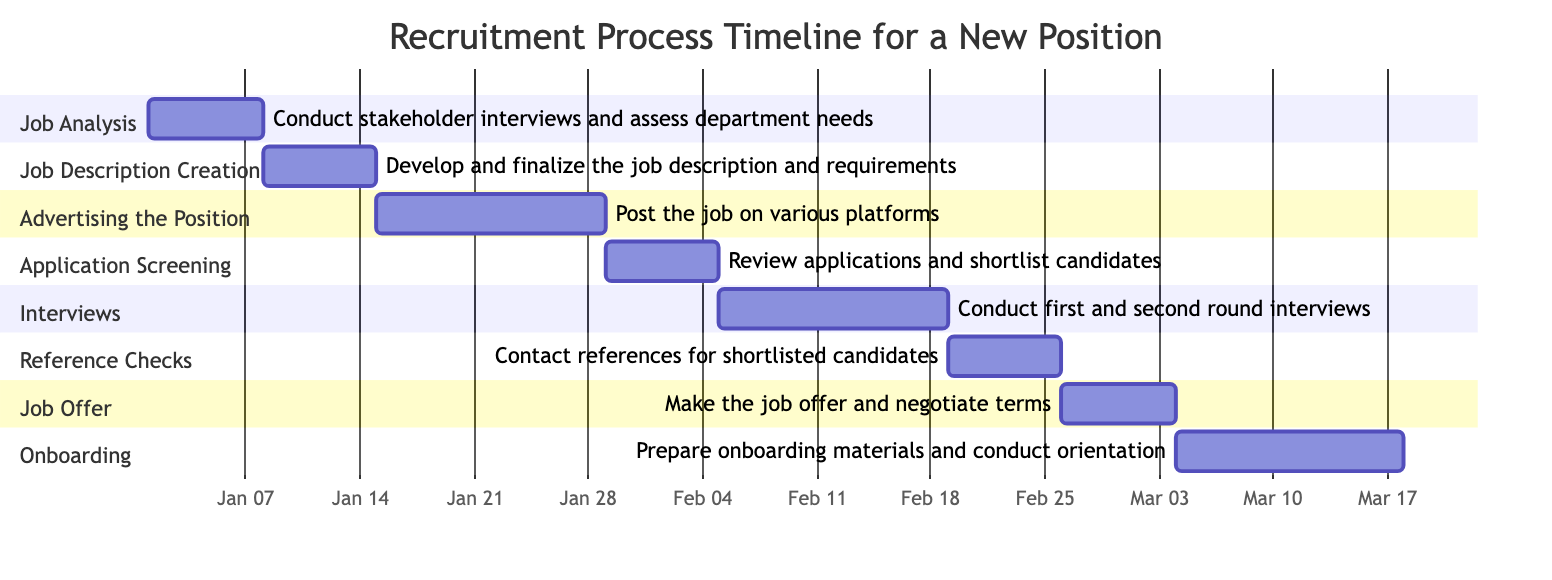What is the duration of the "Job Analysis" phase? The duration for the "Job Analysis" phase is explicitly noted in the diagram data as "1 week."
Answer: 1 week When does the "Interviews" phase start? The "Interviews" phase starts immediately after the "Application Screening" phase ends, which is noted to be on February 4, 2024. Therefore, it begins on February 5, 2024.
Answer: February 5, 2024 How many weeks does the entire recruitment process take? To find the total duration, we identify the end of the last phase, "Onboarding," which concludes on March 17, 2024. The recruitment process starts on January 1, 2024, leading to a total duration of about 10 weeks.
Answer: 10 weeks Which phase follows "Reference Checks"? The "Job Offer" phase directly follows "Reference Checks," as indicated by the sequential flow in the diagram.
Answer: Job Offer What are the tasks involved in the "Advertising the Position" phase? The task noted for the "Advertising the Position" phase is to "Post the job on various platforms (LinkedIn, company website, etc.)," as provided in the phase description.
Answer: Post the job on various platforms (LinkedIn, company website, etc.) How many tasks are involved in the "Interviews" phase? There is one task specified for the "Interviews" phase, which is to "Conduct first and second round interviews," as detailed in the diagram.
Answer: Conduct first and second round interviews What is the start date of the "Onboarding" phase? The "Onboarding" phase starts right after the "Job Offer" phase, which concludes on March 3, 2024. Thus, "Onboarding" begins on March 4, 2024.
Answer: March 4, 2024 How does the “Job Description Creation” phase relate to the “Job Analysis” phase? The "Job Description Creation" phase begins immediately after the "Job Analysis" phase ends, indicating a direct sequential relationship between these two phases in the recruitment process timeline.
Answer: Sequentially follows What is the end date of the "Application Screening" phase? The "Application Screening" phase ends on February 4, 2024, as specified in the diagram data with a start date of January 29, 2024, and a duration of 1 week.
Answer: February 4, 2024 